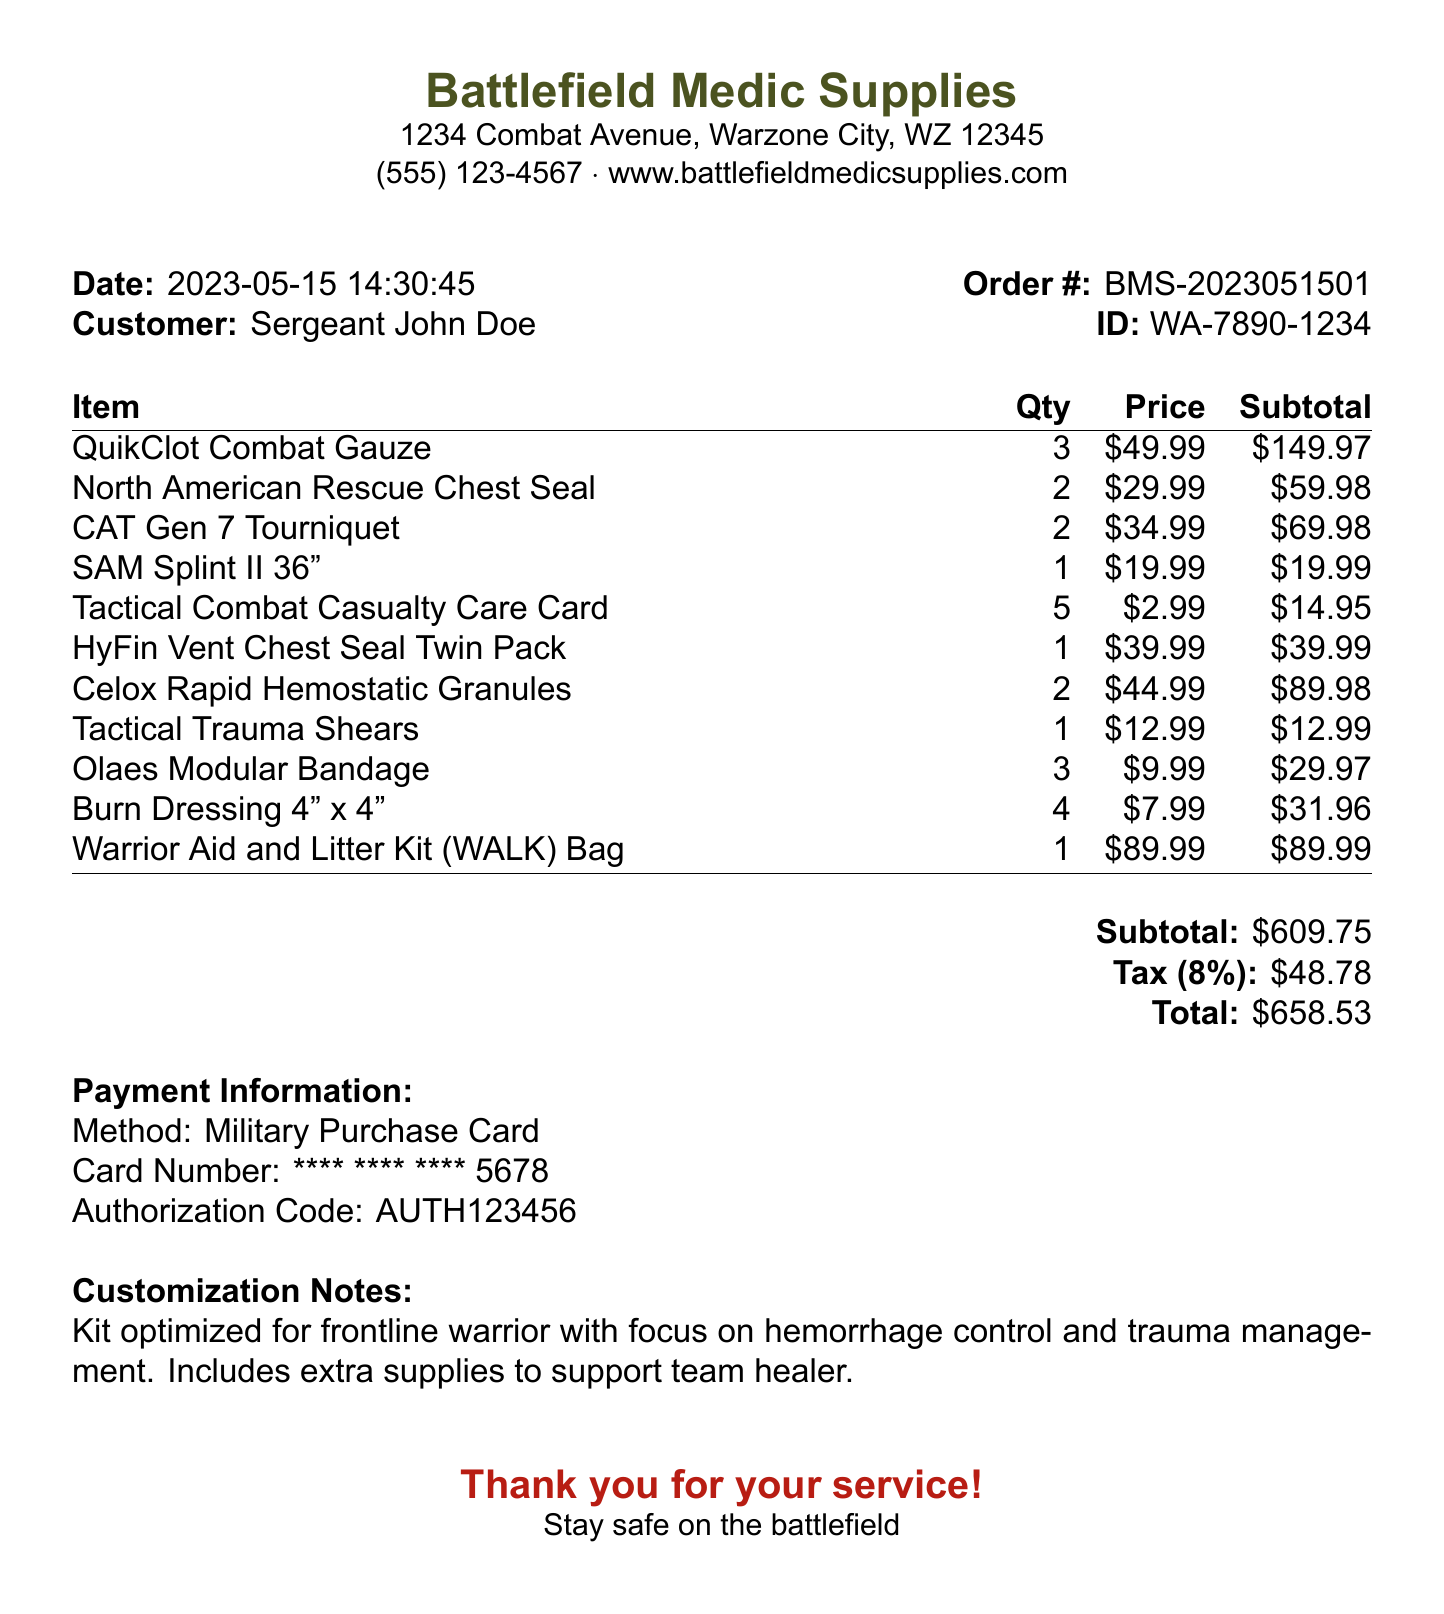What is the store name? The store name is found in the header of the receipt document.
Answer: Battlefield Medic Supplies What is the date of the transaction? The date of the transaction can be located in the receipt header.
Answer: 2023-05-15 What is the total cost of the items purchased? The total cost is the final amount that includes tax, found at the end of the document.
Answer: 658.53 How many QuikClot Combat Gauzes were purchased? The quantity of this item is indicated in the itemized list within the receipt.
Answer: 3 What is the subtotal amount before tax? The subtotal is the summed price of the items before tax, listed towards the bottom of the receipt.
Answer: 609.75 What is the tax rate applied to the purchase? The tax rate is specified next to the tax amount in the totals section of the document.
Answer: 8% What type of payment method was used? The payment method is provided in the payment information section.
Answer: Military Purchase Card What customization notes are given for the first-aid kit? The customization notes provide specific details about the kit's focus, found towards the end of the document.
Answer: Kit optimized for frontline warrior with focus on hemorrhage control and trauma management. Includes extra supplies to support team healer How many Tactical Combat Casualty Care Cards were included? The number of these specific cards is indicated in the itemized section of the receipt.
Answer: 5 